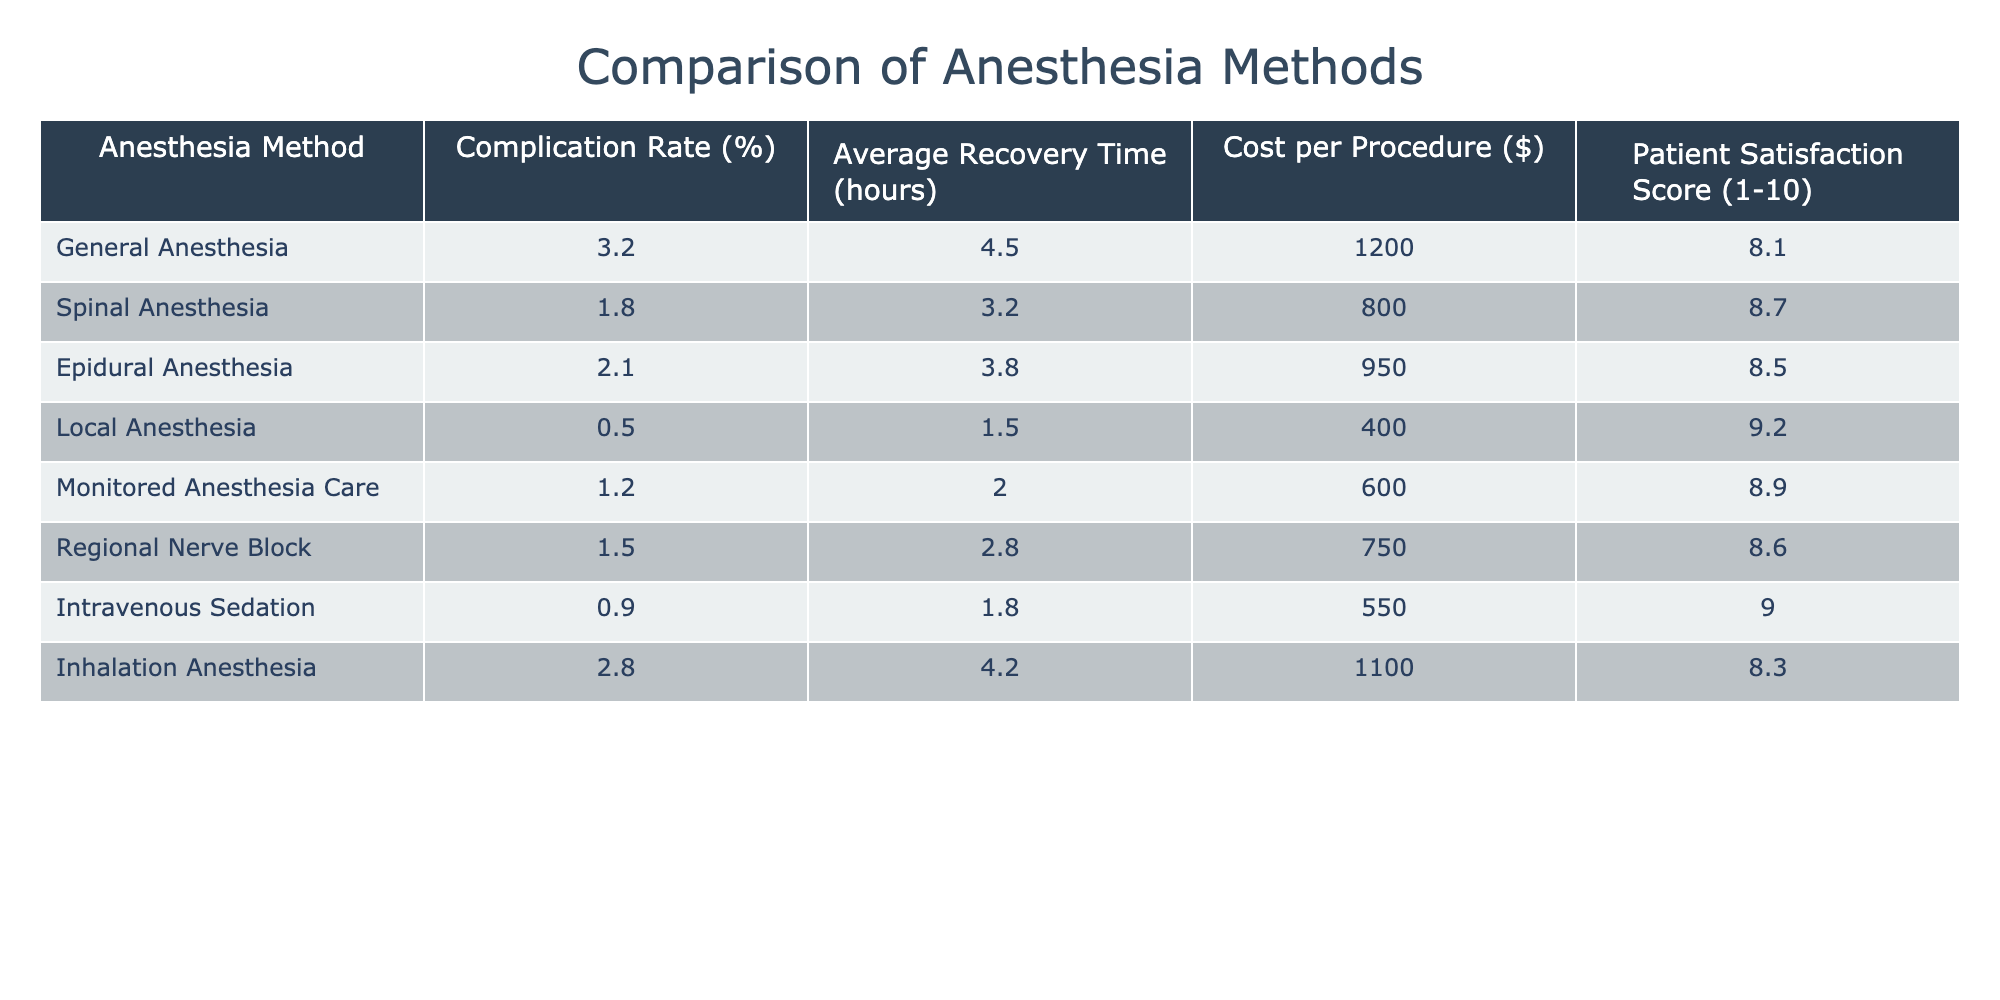What is the complication rate for Local Anesthesia? The table shows the complication rate for Local Anesthesia as 0.5%.
Answer: 0.5% Which anesthesia method has the highest patient satisfaction score? The table lists Local Anesthesia with a patient satisfaction score of 9.2, which is the highest among all methods.
Answer: Local Anesthesia What is the average recovery time for spinal anesthesia? According to the table, the average recovery time for spinal anesthesia is 3.2 hours.
Answer: 3.2 hours How much more does General Anesthesia cost compared to Local Anesthesia? The cost of General Anesthesia is $1200, while Local Anesthesia costs $400. The difference is $1200 - $400 = $800.
Answer: $800 Is the complication rate for Epidural Anesthesia lower than that for Monitored Anesthesia Care? The complication rate for Epidural Anesthesia is 2.1%, while it is 1.2% for Monitored Anesthesia Care, so yes, it is lower.
Answer: No What is the total complication rate for General and Inhalation Anesthesia combined? The complication rates are 3.2% for General Anesthesia and 2.8% for Inhalation Anesthesia. Adding these together gives 3.2% + 2.8% = 6.0%.
Answer: 6.0% If we consider the five anesthesia methods with the lowest complication rates, what is their average complication rate? The five lowest complication rates are Local (0.5%), Intravenous Sedation (0.9%), Monitored Anesthesia Care (1.2%), Regional Nerve Block (1.5%), and Spinal Anesthesia (1.8%). The average is (0.5 + 0.9 + 1.2 + 1.5 + 1.8) / 5 = 1.18%.
Answer: 1.18% Which anesthesia method has the longest average recovery time? The table shows that General Anesthesia has the longest average recovery time at 4.5 hours.
Answer: General Anesthesia What is the difference in patient satisfaction score between Intravenous Sedation and Epidural Anesthesia? Intravenous Sedation has a score of 9.0 and Epidural Anesthesia has 8.5. The difference is 9.0 - 8.5 = 0.5.
Answer: 0.5 Are all anesthesia methods more expensive than Local Anesthesia? The cost of Local Anesthesia is $400. The costs of all other methods are higher, so yes, all are more expensive.
Answer: Yes 